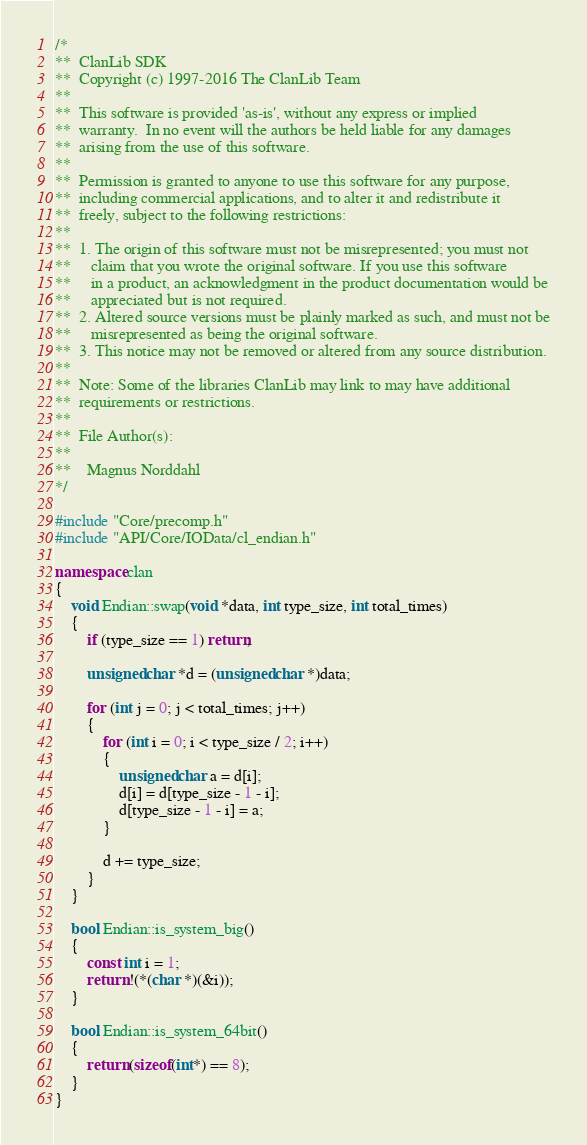Convert code to text. <code><loc_0><loc_0><loc_500><loc_500><_C++_>/*
**  ClanLib SDK
**  Copyright (c) 1997-2016 The ClanLib Team
**
**  This software is provided 'as-is', without any express or implied
**  warranty.  In no event will the authors be held liable for any damages
**  arising from the use of this software.
**
**  Permission is granted to anyone to use this software for any purpose,
**  including commercial applications, and to alter it and redistribute it
**  freely, subject to the following restrictions:
**
**  1. The origin of this software must not be misrepresented; you must not
**     claim that you wrote the original software. If you use this software
**     in a product, an acknowledgment in the product documentation would be
**     appreciated but is not required.
**  2. Altered source versions must be plainly marked as such, and must not be
**     misrepresented as being the original software.
**  3. This notice may not be removed or altered from any source distribution.
**
**  Note: Some of the libraries ClanLib may link to may have additional
**  requirements or restrictions.
**
**  File Author(s):
**
**    Magnus Norddahl
*/

#include "Core/precomp.h"
#include "API/Core/IOData/cl_endian.h"

namespace clan
{
	void Endian::swap(void *data, int type_size, int total_times)
	{
		if (type_size == 1) return;

		unsigned char *d = (unsigned char *)data;

		for (int j = 0; j < total_times; j++)
		{
			for (int i = 0; i < type_size / 2; i++)
			{
				unsigned char a = d[i];
				d[i] = d[type_size - 1 - i];
				d[type_size - 1 - i] = a;
			}

			d += type_size;
		}
	}

	bool Endian::is_system_big()
	{
		const int i = 1;
		return !(*(char *)(&i));
	}

	bool Endian::is_system_64bit()
	{
		return (sizeof(int*) == 8);
	}
}
</code> 